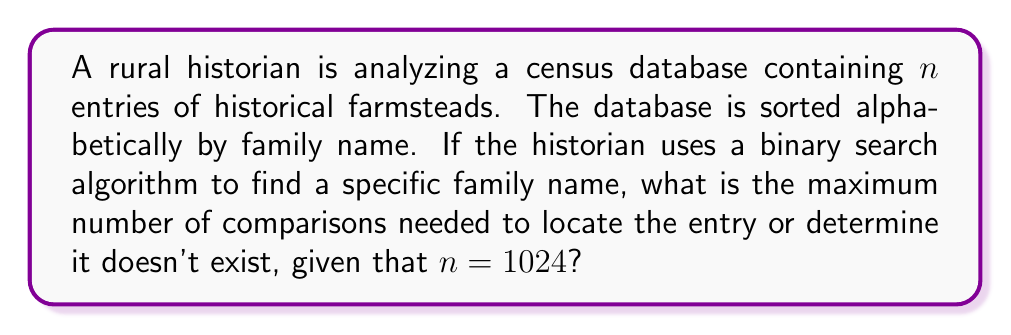Show me your answer to this math problem. To solve this problem, we need to understand how binary search works and its efficiency:

1) Binary search is an efficient algorithm for searching a sorted array by repeatedly dividing the search interval in half.

2) The efficiency of binary search is typically expressed as $O(\log_2 n)$, where $n$ is the number of elements in the array.

3) To find the maximum number of comparisons, we need to calculate $\lfloor \log_2 n \rfloor + 1$, where $\lfloor \rfloor$ denotes the floor function.

4) In this case, $n = 1024$

5) $\log_2 1024 = 10$ (since $2^{10} = 1024$)

6) Therefore, $\lfloor \log_2 1024 \rfloor + 1 = 10 + 1 = 11$

This means that in the worst-case scenario (when the searched element is either the last one to be checked or doesn't exist in the array), the algorithm will need at most 11 comparisons.

For a rural historian, this means that even with a large database of 1024 historical farmsteads, any specific family name can be found (or determined to be absent) with at most 11 checks, which is much more efficient than checking each entry one by one (which would require up to 1024 checks in the worst case).
Answer: 11 comparisons 